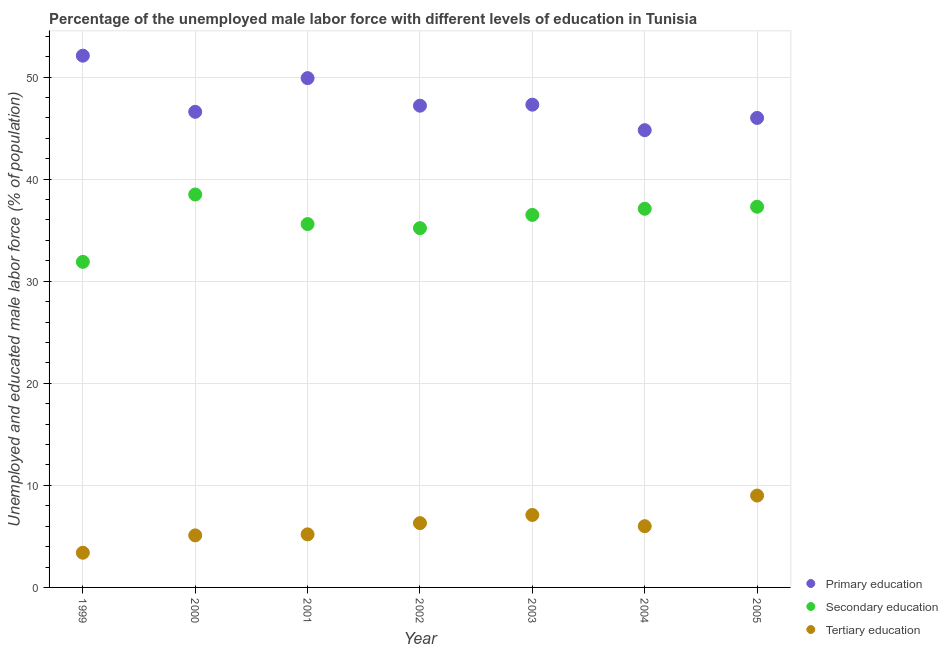How many different coloured dotlines are there?
Provide a succinct answer. 3. Is the number of dotlines equal to the number of legend labels?
Provide a short and direct response. Yes. What is the percentage of male labor force who received primary education in 1999?
Offer a very short reply. 52.1. Across all years, what is the maximum percentage of male labor force who received secondary education?
Provide a short and direct response. 38.5. Across all years, what is the minimum percentage of male labor force who received secondary education?
Your answer should be very brief. 31.9. In which year was the percentage of male labor force who received tertiary education minimum?
Offer a terse response. 1999. What is the total percentage of male labor force who received secondary education in the graph?
Your response must be concise. 252.1. What is the difference between the percentage of male labor force who received tertiary education in 2002 and that in 2005?
Provide a short and direct response. -2.7. What is the difference between the percentage of male labor force who received secondary education in 2003 and the percentage of male labor force who received tertiary education in 2000?
Provide a short and direct response. 31.4. What is the average percentage of male labor force who received secondary education per year?
Ensure brevity in your answer.  36.01. In the year 2002, what is the difference between the percentage of male labor force who received tertiary education and percentage of male labor force who received secondary education?
Keep it short and to the point. -28.9. What is the ratio of the percentage of male labor force who received tertiary education in 1999 to that in 2005?
Your answer should be compact. 0.38. What is the difference between the highest and the second highest percentage of male labor force who received tertiary education?
Provide a short and direct response. 1.9. What is the difference between the highest and the lowest percentage of male labor force who received primary education?
Keep it short and to the point. 7.3. Is the sum of the percentage of male labor force who received tertiary education in 1999 and 2000 greater than the maximum percentage of male labor force who received primary education across all years?
Provide a succinct answer. No. Is the percentage of male labor force who received secondary education strictly greater than the percentage of male labor force who received primary education over the years?
Ensure brevity in your answer.  No. How many dotlines are there?
Your answer should be very brief. 3. How many years are there in the graph?
Your answer should be very brief. 7. Does the graph contain any zero values?
Your answer should be very brief. No. Does the graph contain grids?
Ensure brevity in your answer.  Yes. How many legend labels are there?
Offer a very short reply. 3. How are the legend labels stacked?
Your answer should be compact. Vertical. What is the title of the graph?
Offer a terse response. Percentage of the unemployed male labor force with different levels of education in Tunisia. What is the label or title of the X-axis?
Ensure brevity in your answer.  Year. What is the label or title of the Y-axis?
Your answer should be compact. Unemployed and educated male labor force (% of population). What is the Unemployed and educated male labor force (% of population) in Primary education in 1999?
Offer a terse response. 52.1. What is the Unemployed and educated male labor force (% of population) of Secondary education in 1999?
Offer a terse response. 31.9. What is the Unemployed and educated male labor force (% of population) in Tertiary education in 1999?
Provide a succinct answer. 3.4. What is the Unemployed and educated male labor force (% of population) in Primary education in 2000?
Offer a terse response. 46.6. What is the Unemployed and educated male labor force (% of population) in Secondary education in 2000?
Provide a succinct answer. 38.5. What is the Unemployed and educated male labor force (% of population) of Tertiary education in 2000?
Your response must be concise. 5.1. What is the Unemployed and educated male labor force (% of population) of Primary education in 2001?
Your answer should be very brief. 49.9. What is the Unemployed and educated male labor force (% of population) of Secondary education in 2001?
Your answer should be very brief. 35.6. What is the Unemployed and educated male labor force (% of population) of Tertiary education in 2001?
Provide a short and direct response. 5.2. What is the Unemployed and educated male labor force (% of population) of Primary education in 2002?
Offer a very short reply. 47.2. What is the Unemployed and educated male labor force (% of population) in Secondary education in 2002?
Offer a very short reply. 35.2. What is the Unemployed and educated male labor force (% of population) in Tertiary education in 2002?
Keep it short and to the point. 6.3. What is the Unemployed and educated male labor force (% of population) in Primary education in 2003?
Keep it short and to the point. 47.3. What is the Unemployed and educated male labor force (% of population) of Secondary education in 2003?
Offer a terse response. 36.5. What is the Unemployed and educated male labor force (% of population) of Tertiary education in 2003?
Give a very brief answer. 7.1. What is the Unemployed and educated male labor force (% of population) of Primary education in 2004?
Offer a very short reply. 44.8. What is the Unemployed and educated male labor force (% of population) in Secondary education in 2004?
Your answer should be very brief. 37.1. What is the Unemployed and educated male labor force (% of population) of Tertiary education in 2004?
Ensure brevity in your answer.  6. What is the Unemployed and educated male labor force (% of population) of Primary education in 2005?
Keep it short and to the point. 46. What is the Unemployed and educated male labor force (% of population) of Secondary education in 2005?
Your answer should be compact. 37.3. Across all years, what is the maximum Unemployed and educated male labor force (% of population) of Primary education?
Provide a short and direct response. 52.1. Across all years, what is the maximum Unemployed and educated male labor force (% of population) in Secondary education?
Ensure brevity in your answer.  38.5. Across all years, what is the minimum Unemployed and educated male labor force (% of population) in Primary education?
Offer a terse response. 44.8. Across all years, what is the minimum Unemployed and educated male labor force (% of population) in Secondary education?
Give a very brief answer. 31.9. Across all years, what is the minimum Unemployed and educated male labor force (% of population) of Tertiary education?
Give a very brief answer. 3.4. What is the total Unemployed and educated male labor force (% of population) in Primary education in the graph?
Your answer should be very brief. 333.9. What is the total Unemployed and educated male labor force (% of population) of Secondary education in the graph?
Provide a short and direct response. 252.1. What is the total Unemployed and educated male labor force (% of population) in Tertiary education in the graph?
Give a very brief answer. 42.1. What is the difference between the Unemployed and educated male labor force (% of population) of Primary education in 1999 and that in 2001?
Your response must be concise. 2.2. What is the difference between the Unemployed and educated male labor force (% of population) of Secondary education in 1999 and that in 2002?
Your answer should be very brief. -3.3. What is the difference between the Unemployed and educated male labor force (% of population) in Primary education in 1999 and that in 2003?
Provide a short and direct response. 4.8. What is the difference between the Unemployed and educated male labor force (% of population) in Secondary education in 1999 and that in 2003?
Your response must be concise. -4.6. What is the difference between the Unemployed and educated male labor force (% of population) of Tertiary education in 1999 and that in 2003?
Provide a short and direct response. -3.7. What is the difference between the Unemployed and educated male labor force (% of population) in Primary education in 1999 and that in 2004?
Provide a succinct answer. 7.3. What is the difference between the Unemployed and educated male labor force (% of population) in Secondary education in 1999 and that in 2004?
Your answer should be very brief. -5.2. What is the difference between the Unemployed and educated male labor force (% of population) of Tertiary education in 1999 and that in 2004?
Your answer should be compact. -2.6. What is the difference between the Unemployed and educated male labor force (% of population) of Secondary education in 1999 and that in 2005?
Keep it short and to the point. -5.4. What is the difference between the Unemployed and educated male labor force (% of population) in Tertiary education in 1999 and that in 2005?
Provide a short and direct response. -5.6. What is the difference between the Unemployed and educated male labor force (% of population) of Secondary education in 2000 and that in 2001?
Keep it short and to the point. 2.9. What is the difference between the Unemployed and educated male labor force (% of population) of Primary education in 2000 and that in 2002?
Make the answer very short. -0.6. What is the difference between the Unemployed and educated male labor force (% of population) of Tertiary education in 2000 and that in 2002?
Make the answer very short. -1.2. What is the difference between the Unemployed and educated male labor force (% of population) in Secondary education in 2000 and that in 2004?
Give a very brief answer. 1.4. What is the difference between the Unemployed and educated male labor force (% of population) in Primary education in 2000 and that in 2005?
Give a very brief answer. 0.6. What is the difference between the Unemployed and educated male labor force (% of population) in Secondary education in 2000 and that in 2005?
Your answer should be compact. 1.2. What is the difference between the Unemployed and educated male labor force (% of population) of Primary education in 2001 and that in 2002?
Your answer should be compact. 2.7. What is the difference between the Unemployed and educated male labor force (% of population) of Primary education in 2001 and that in 2004?
Offer a very short reply. 5.1. What is the difference between the Unemployed and educated male labor force (% of population) of Secondary education in 2001 and that in 2005?
Offer a terse response. -1.7. What is the difference between the Unemployed and educated male labor force (% of population) of Tertiary education in 2002 and that in 2004?
Provide a short and direct response. 0.3. What is the difference between the Unemployed and educated male labor force (% of population) of Secondary education in 2002 and that in 2005?
Provide a short and direct response. -2.1. What is the difference between the Unemployed and educated male labor force (% of population) of Tertiary education in 2002 and that in 2005?
Keep it short and to the point. -2.7. What is the difference between the Unemployed and educated male labor force (% of population) of Primary education in 2003 and that in 2004?
Provide a succinct answer. 2.5. What is the difference between the Unemployed and educated male labor force (% of population) in Tertiary education in 2003 and that in 2004?
Provide a succinct answer. 1.1. What is the difference between the Unemployed and educated male labor force (% of population) of Primary education in 2003 and that in 2005?
Provide a short and direct response. 1.3. What is the difference between the Unemployed and educated male labor force (% of population) of Secondary education in 2003 and that in 2005?
Keep it short and to the point. -0.8. What is the difference between the Unemployed and educated male labor force (% of population) of Tertiary education in 2004 and that in 2005?
Provide a succinct answer. -3. What is the difference between the Unemployed and educated male labor force (% of population) of Primary education in 1999 and the Unemployed and educated male labor force (% of population) of Secondary education in 2000?
Give a very brief answer. 13.6. What is the difference between the Unemployed and educated male labor force (% of population) in Secondary education in 1999 and the Unemployed and educated male labor force (% of population) in Tertiary education in 2000?
Give a very brief answer. 26.8. What is the difference between the Unemployed and educated male labor force (% of population) in Primary education in 1999 and the Unemployed and educated male labor force (% of population) in Secondary education in 2001?
Your answer should be compact. 16.5. What is the difference between the Unemployed and educated male labor force (% of population) of Primary education in 1999 and the Unemployed and educated male labor force (% of population) of Tertiary education in 2001?
Provide a succinct answer. 46.9. What is the difference between the Unemployed and educated male labor force (% of population) in Secondary education in 1999 and the Unemployed and educated male labor force (% of population) in Tertiary education in 2001?
Make the answer very short. 26.7. What is the difference between the Unemployed and educated male labor force (% of population) in Primary education in 1999 and the Unemployed and educated male labor force (% of population) in Secondary education in 2002?
Keep it short and to the point. 16.9. What is the difference between the Unemployed and educated male labor force (% of population) in Primary education in 1999 and the Unemployed and educated male labor force (% of population) in Tertiary education in 2002?
Offer a very short reply. 45.8. What is the difference between the Unemployed and educated male labor force (% of population) of Secondary education in 1999 and the Unemployed and educated male labor force (% of population) of Tertiary education in 2002?
Offer a terse response. 25.6. What is the difference between the Unemployed and educated male labor force (% of population) of Secondary education in 1999 and the Unemployed and educated male labor force (% of population) of Tertiary education in 2003?
Keep it short and to the point. 24.8. What is the difference between the Unemployed and educated male labor force (% of population) of Primary education in 1999 and the Unemployed and educated male labor force (% of population) of Secondary education in 2004?
Your answer should be compact. 15. What is the difference between the Unemployed and educated male labor force (% of population) in Primary education in 1999 and the Unemployed and educated male labor force (% of population) in Tertiary education in 2004?
Provide a succinct answer. 46.1. What is the difference between the Unemployed and educated male labor force (% of population) in Secondary education in 1999 and the Unemployed and educated male labor force (% of population) in Tertiary education in 2004?
Your answer should be very brief. 25.9. What is the difference between the Unemployed and educated male labor force (% of population) in Primary education in 1999 and the Unemployed and educated male labor force (% of population) in Tertiary education in 2005?
Make the answer very short. 43.1. What is the difference between the Unemployed and educated male labor force (% of population) of Secondary education in 1999 and the Unemployed and educated male labor force (% of population) of Tertiary education in 2005?
Offer a very short reply. 22.9. What is the difference between the Unemployed and educated male labor force (% of population) in Primary education in 2000 and the Unemployed and educated male labor force (% of population) in Secondary education in 2001?
Provide a succinct answer. 11. What is the difference between the Unemployed and educated male labor force (% of population) in Primary education in 2000 and the Unemployed and educated male labor force (% of population) in Tertiary education in 2001?
Your response must be concise. 41.4. What is the difference between the Unemployed and educated male labor force (% of population) in Secondary education in 2000 and the Unemployed and educated male labor force (% of population) in Tertiary education in 2001?
Your response must be concise. 33.3. What is the difference between the Unemployed and educated male labor force (% of population) in Primary education in 2000 and the Unemployed and educated male labor force (% of population) in Secondary education in 2002?
Your answer should be compact. 11.4. What is the difference between the Unemployed and educated male labor force (% of population) of Primary education in 2000 and the Unemployed and educated male labor force (% of population) of Tertiary education in 2002?
Keep it short and to the point. 40.3. What is the difference between the Unemployed and educated male labor force (% of population) in Secondary education in 2000 and the Unemployed and educated male labor force (% of population) in Tertiary education in 2002?
Provide a succinct answer. 32.2. What is the difference between the Unemployed and educated male labor force (% of population) in Primary education in 2000 and the Unemployed and educated male labor force (% of population) in Tertiary education in 2003?
Provide a succinct answer. 39.5. What is the difference between the Unemployed and educated male labor force (% of population) of Secondary education in 2000 and the Unemployed and educated male labor force (% of population) of Tertiary education in 2003?
Provide a short and direct response. 31.4. What is the difference between the Unemployed and educated male labor force (% of population) in Primary education in 2000 and the Unemployed and educated male labor force (% of population) in Tertiary education in 2004?
Your answer should be compact. 40.6. What is the difference between the Unemployed and educated male labor force (% of population) of Secondary education in 2000 and the Unemployed and educated male labor force (% of population) of Tertiary education in 2004?
Your answer should be very brief. 32.5. What is the difference between the Unemployed and educated male labor force (% of population) in Primary education in 2000 and the Unemployed and educated male labor force (% of population) in Secondary education in 2005?
Ensure brevity in your answer.  9.3. What is the difference between the Unemployed and educated male labor force (% of population) in Primary education in 2000 and the Unemployed and educated male labor force (% of population) in Tertiary education in 2005?
Give a very brief answer. 37.6. What is the difference between the Unemployed and educated male labor force (% of population) of Secondary education in 2000 and the Unemployed and educated male labor force (% of population) of Tertiary education in 2005?
Keep it short and to the point. 29.5. What is the difference between the Unemployed and educated male labor force (% of population) of Primary education in 2001 and the Unemployed and educated male labor force (% of population) of Secondary education in 2002?
Ensure brevity in your answer.  14.7. What is the difference between the Unemployed and educated male labor force (% of population) in Primary education in 2001 and the Unemployed and educated male labor force (% of population) in Tertiary education in 2002?
Make the answer very short. 43.6. What is the difference between the Unemployed and educated male labor force (% of population) of Secondary education in 2001 and the Unemployed and educated male labor force (% of population) of Tertiary education in 2002?
Give a very brief answer. 29.3. What is the difference between the Unemployed and educated male labor force (% of population) of Primary education in 2001 and the Unemployed and educated male labor force (% of population) of Tertiary education in 2003?
Provide a short and direct response. 42.8. What is the difference between the Unemployed and educated male labor force (% of population) in Primary education in 2001 and the Unemployed and educated male labor force (% of population) in Secondary education in 2004?
Your answer should be very brief. 12.8. What is the difference between the Unemployed and educated male labor force (% of population) in Primary education in 2001 and the Unemployed and educated male labor force (% of population) in Tertiary education in 2004?
Offer a very short reply. 43.9. What is the difference between the Unemployed and educated male labor force (% of population) of Secondary education in 2001 and the Unemployed and educated male labor force (% of population) of Tertiary education in 2004?
Your answer should be very brief. 29.6. What is the difference between the Unemployed and educated male labor force (% of population) in Primary education in 2001 and the Unemployed and educated male labor force (% of population) in Tertiary education in 2005?
Offer a very short reply. 40.9. What is the difference between the Unemployed and educated male labor force (% of population) of Secondary education in 2001 and the Unemployed and educated male labor force (% of population) of Tertiary education in 2005?
Provide a short and direct response. 26.6. What is the difference between the Unemployed and educated male labor force (% of population) in Primary education in 2002 and the Unemployed and educated male labor force (% of population) in Tertiary education in 2003?
Your response must be concise. 40.1. What is the difference between the Unemployed and educated male labor force (% of population) of Secondary education in 2002 and the Unemployed and educated male labor force (% of population) of Tertiary education in 2003?
Ensure brevity in your answer.  28.1. What is the difference between the Unemployed and educated male labor force (% of population) of Primary education in 2002 and the Unemployed and educated male labor force (% of population) of Tertiary education in 2004?
Ensure brevity in your answer.  41.2. What is the difference between the Unemployed and educated male labor force (% of population) in Secondary education in 2002 and the Unemployed and educated male labor force (% of population) in Tertiary education in 2004?
Keep it short and to the point. 29.2. What is the difference between the Unemployed and educated male labor force (% of population) in Primary education in 2002 and the Unemployed and educated male labor force (% of population) in Tertiary education in 2005?
Your response must be concise. 38.2. What is the difference between the Unemployed and educated male labor force (% of population) in Secondary education in 2002 and the Unemployed and educated male labor force (% of population) in Tertiary education in 2005?
Your answer should be compact. 26.2. What is the difference between the Unemployed and educated male labor force (% of population) in Primary education in 2003 and the Unemployed and educated male labor force (% of population) in Tertiary education in 2004?
Offer a very short reply. 41.3. What is the difference between the Unemployed and educated male labor force (% of population) in Secondary education in 2003 and the Unemployed and educated male labor force (% of population) in Tertiary education in 2004?
Make the answer very short. 30.5. What is the difference between the Unemployed and educated male labor force (% of population) of Primary education in 2003 and the Unemployed and educated male labor force (% of population) of Secondary education in 2005?
Provide a succinct answer. 10. What is the difference between the Unemployed and educated male labor force (% of population) of Primary education in 2003 and the Unemployed and educated male labor force (% of population) of Tertiary education in 2005?
Your response must be concise. 38.3. What is the difference between the Unemployed and educated male labor force (% of population) in Secondary education in 2003 and the Unemployed and educated male labor force (% of population) in Tertiary education in 2005?
Give a very brief answer. 27.5. What is the difference between the Unemployed and educated male labor force (% of population) in Primary education in 2004 and the Unemployed and educated male labor force (% of population) in Secondary education in 2005?
Give a very brief answer. 7.5. What is the difference between the Unemployed and educated male labor force (% of population) in Primary education in 2004 and the Unemployed and educated male labor force (% of population) in Tertiary education in 2005?
Provide a short and direct response. 35.8. What is the difference between the Unemployed and educated male labor force (% of population) of Secondary education in 2004 and the Unemployed and educated male labor force (% of population) of Tertiary education in 2005?
Make the answer very short. 28.1. What is the average Unemployed and educated male labor force (% of population) in Primary education per year?
Offer a terse response. 47.7. What is the average Unemployed and educated male labor force (% of population) in Secondary education per year?
Your answer should be compact. 36.01. What is the average Unemployed and educated male labor force (% of population) of Tertiary education per year?
Offer a terse response. 6.01. In the year 1999, what is the difference between the Unemployed and educated male labor force (% of population) in Primary education and Unemployed and educated male labor force (% of population) in Secondary education?
Offer a very short reply. 20.2. In the year 1999, what is the difference between the Unemployed and educated male labor force (% of population) of Primary education and Unemployed and educated male labor force (% of population) of Tertiary education?
Your response must be concise. 48.7. In the year 2000, what is the difference between the Unemployed and educated male labor force (% of population) of Primary education and Unemployed and educated male labor force (% of population) of Tertiary education?
Your answer should be compact. 41.5. In the year 2000, what is the difference between the Unemployed and educated male labor force (% of population) of Secondary education and Unemployed and educated male labor force (% of population) of Tertiary education?
Offer a very short reply. 33.4. In the year 2001, what is the difference between the Unemployed and educated male labor force (% of population) in Primary education and Unemployed and educated male labor force (% of population) in Tertiary education?
Offer a terse response. 44.7. In the year 2001, what is the difference between the Unemployed and educated male labor force (% of population) in Secondary education and Unemployed and educated male labor force (% of population) in Tertiary education?
Your response must be concise. 30.4. In the year 2002, what is the difference between the Unemployed and educated male labor force (% of population) in Primary education and Unemployed and educated male labor force (% of population) in Secondary education?
Your response must be concise. 12. In the year 2002, what is the difference between the Unemployed and educated male labor force (% of population) in Primary education and Unemployed and educated male labor force (% of population) in Tertiary education?
Make the answer very short. 40.9. In the year 2002, what is the difference between the Unemployed and educated male labor force (% of population) of Secondary education and Unemployed and educated male labor force (% of population) of Tertiary education?
Your answer should be compact. 28.9. In the year 2003, what is the difference between the Unemployed and educated male labor force (% of population) in Primary education and Unemployed and educated male labor force (% of population) in Tertiary education?
Make the answer very short. 40.2. In the year 2003, what is the difference between the Unemployed and educated male labor force (% of population) in Secondary education and Unemployed and educated male labor force (% of population) in Tertiary education?
Ensure brevity in your answer.  29.4. In the year 2004, what is the difference between the Unemployed and educated male labor force (% of population) of Primary education and Unemployed and educated male labor force (% of population) of Secondary education?
Your answer should be compact. 7.7. In the year 2004, what is the difference between the Unemployed and educated male labor force (% of population) in Primary education and Unemployed and educated male labor force (% of population) in Tertiary education?
Offer a terse response. 38.8. In the year 2004, what is the difference between the Unemployed and educated male labor force (% of population) of Secondary education and Unemployed and educated male labor force (% of population) of Tertiary education?
Keep it short and to the point. 31.1. In the year 2005, what is the difference between the Unemployed and educated male labor force (% of population) in Primary education and Unemployed and educated male labor force (% of population) in Tertiary education?
Your response must be concise. 37. In the year 2005, what is the difference between the Unemployed and educated male labor force (% of population) of Secondary education and Unemployed and educated male labor force (% of population) of Tertiary education?
Give a very brief answer. 28.3. What is the ratio of the Unemployed and educated male labor force (% of population) in Primary education in 1999 to that in 2000?
Your answer should be very brief. 1.12. What is the ratio of the Unemployed and educated male labor force (% of population) of Secondary education in 1999 to that in 2000?
Provide a succinct answer. 0.83. What is the ratio of the Unemployed and educated male labor force (% of population) of Primary education in 1999 to that in 2001?
Keep it short and to the point. 1.04. What is the ratio of the Unemployed and educated male labor force (% of population) in Secondary education in 1999 to that in 2001?
Make the answer very short. 0.9. What is the ratio of the Unemployed and educated male labor force (% of population) in Tertiary education in 1999 to that in 2001?
Provide a short and direct response. 0.65. What is the ratio of the Unemployed and educated male labor force (% of population) of Primary education in 1999 to that in 2002?
Offer a very short reply. 1.1. What is the ratio of the Unemployed and educated male labor force (% of population) in Secondary education in 1999 to that in 2002?
Your answer should be compact. 0.91. What is the ratio of the Unemployed and educated male labor force (% of population) in Tertiary education in 1999 to that in 2002?
Give a very brief answer. 0.54. What is the ratio of the Unemployed and educated male labor force (% of population) of Primary education in 1999 to that in 2003?
Provide a succinct answer. 1.1. What is the ratio of the Unemployed and educated male labor force (% of population) of Secondary education in 1999 to that in 2003?
Your answer should be compact. 0.87. What is the ratio of the Unemployed and educated male labor force (% of population) in Tertiary education in 1999 to that in 2003?
Offer a very short reply. 0.48. What is the ratio of the Unemployed and educated male labor force (% of population) in Primary education in 1999 to that in 2004?
Provide a short and direct response. 1.16. What is the ratio of the Unemployed and educated male labor force (% of population) in Secondary education in 1999 to that in 2004?
Offer a very short reply. 0.86. What is the ratio of the Unemployed and educated male labor force (% of population) in Tertiary education in 1999 to that in 2004?
Keep it short and to the point. 0.57. What is the ratio of the Unemployed and educated male labor force (% of population) in Primary education in 1999 to that in 2005?
Keep it short and to the point. 1.13. What is the ratio of the Unemployed and educated male labor force (% of population) of Secondary education in 1999 to that in 2005?
Provide a short and direct response. 0.86. What is the ratio of the Unemployed and educated male labor force (% of population) of Tertiary education in 1999 to that in 2005?
Your answer should be compact. 0.38. What is the ratio of the Unemployed and educated male labor force (% of population) in Primary education in 2000 to that in 2001?
Provide a short and direct response. 0.93. What is the ratio of the Unemployed and educated male labor force (% of population) in Secondary education in 2000 to that in 2001?
Offer a terse response. 1.08. What is the ratio of the Unemployed and educated male labor force (% of population) of Tertiary education in 2000 to that in 2001?
Provide a succinct answer. 0.98. What is the ratio of the Unemployed and educated male labor force (% of population) in Primary education in 2000 to that in 2002?
Your answer should be compact. 0.99. What is the ratio of the Unemployed and educated male labor force (% of population) of Secondary education in 2000 to that in 2002?
Provide a short and direct response. 1.09. What is the ratio of the Unemployed and educated male labor force (% of population) of Tertiary education in 2000 to that in 2002?
Your answer should be compact. 0.81. What is the ratio of the Unemployed and educated male labor force (% of population) in Primary education in 2000 to that in 2003?
Offer a terse response. 0.99. What is the ratio of the Unemployed and educated male labor force (% of population) of Secondary education in 2000 to that in 2003?
Your answer should be very brief. 1.05. What is the ratio of the Unemployed and educated male labor force (% of population) in Tertiary education in 2000 to that in 2003?
Make the answer very short. 0.72. What is the ratio of the Unemployed and educated male labor force (% of population) in Primary education in 2000 to that in 2004?
Make the answer very short. 1.04. What is the ratio of the Unemployed and educated male labor force (% of population) of Secondary education in 2000 to that in 2004?
Your response must be concise. 1.04. What is the ratio of the Unemployed and educated male labor force (% of population) in Tertiary education in 2000 to that in 2004?
Provide a succinct answer. 0.85. What is the ratio of the Unemployed and educated male labor force (% of population) in Secondary education in 2000 to that in 2005?
Give a very brief answer. 1.03. What is the ratio of the Unemployed and educated male labor force (% of population) of Tertiary education in 2000 to that in 2005?
Your response must be concise. 0.57. What is the ratio of the Unemployed and educated male labor force (% of population) of Primary education in 2001 to that in 2002?
Your answer should be compact. 1.06. What is the ratio of the Unemployed and educated male labor force (% of population) in Secondary education in 2001 to that in 2002?
Offer a very short reply. 1.01. What is the ratio of the Unemployed and educated male labor force (% of population) in Tertiary education in 2001 to that in 2002?
Offer a terse response. 0.83. What is the ratio of the Unemployed and educated male labor force (% of population) of Primary education in 2001 to that in 2003?
Your response must be concise. 1.05. What is the ratio of the Unemployed and educated male labor force (% of population) in Secondary education in 2001 to that in 2003?
Your response must be concise. 0.98. What is the ratio of the Unemployed and educated male labor force (% of population) in Tertiary education in 2001 to that in 2003?
Your answer should be very brief. 0.73. What is the ratio of the Unemployed and educated male labor force (% of population) in Primary education in 2001 to that in 2004?
Provide a short and direct response. 1.11. What is the ratio of the Unemployed and educated male labor force (% of population) of Secondary education in 2001 to that in 2004?
Offer a terse response. 0.96. What is the ratio of the Unemployed and educated male labor force (% of population) of Tertiary education in 2001 to that in 2004?
Ensure brevity in your answer.  0.87. What is the ratio of the Unemployed and educated male labor force (% of population) in Primary education in 2001 to that in 2005?
Your answer should be very brief. 1.08. What is the ratio of the Unemployed and educated male labor force (% of population) in Secondary education in 2001 to that in 2005?
Keep it short and to the point. 0.95. What is the ratio of the Unemployed and educated male labor force (% of population) of Tertiary education in 2001 to that in 2005?
Your answer should be compact. 0.58. What is the ratio of the Unemployed and educated male labor force (% of population) of Secondary education in 2002 to that in 2003?
Offer a very short reply. 0.96. What is the ratio of the Unemployed and educated male labor force (% of population) of Tertiary education in 2002 to that in 2003?
Give a very brief answer. 0.89. What is the ratio of the Unemployed and educated male labor force (% of population) in Primary education in 2002 to that in 2004?
Offer a terse response. 1.05. What is the ratio of the Unemployed and educated male labor force (% of population) in Secondary education in 2002 to that in 2004?
Offer a very short reply. 0.95. What is the ratio of the Unemployed and educated male labor force (% of population) of Primary education in 2002 to that in 2005?
Keep it short and to the point. 1.03. What is the ratio of the Unemployed and educated male labor force (% of population) in Secondary education in 2002 to that in 2005?
Ensure brevity in your answer.  0.94. What is the ratio of the Unemployed and educated male labor force (% of population) in Primary education in 2003 to that in 2004?
Your answer should be very brief. 1.06. What is the ratio of the Unemployed and educated male labor force (% of population) of Secondary education in 2003 to that in 2004?
Your response must be concise. 0.98. What is the ratio of the Unemployed and educated male labor force (% of population) in Tertiary education in 2003 to that in 2004?
Your answer should be compact. 1.18. What is the ratio of the Unemployed and educated male labor force (% of population) in Primary education in 2003 to that in 2005?
Your answer should be very brief. 1.03. What is the ratio of the Unemployed and educated male labor force (% of population) of Secondary education in 2003 to that in 2005?
Your response must be concise. 0.98. What is the ratio of the Unemployed and educated male labor force (% of population) in Tertiary education in 2003 to that in 2005?
Provide a short and direct response. 0.79. What is the ratio of the Unemployed and educated male labor force (% of population) in Primary education in 2004 to that in 2005?
Your answer should be compact. 0.97. What is the ratio of the Unemployed and educated male labor force (% of population) of Tertiary education in 2004 to that in 2005?
Provide a short and direct response. 0.67. What is the difference between the highest and the lowest Unemployed and educated male labor force (% of population) of Primary education?
Make the answer very short. 7.3. 